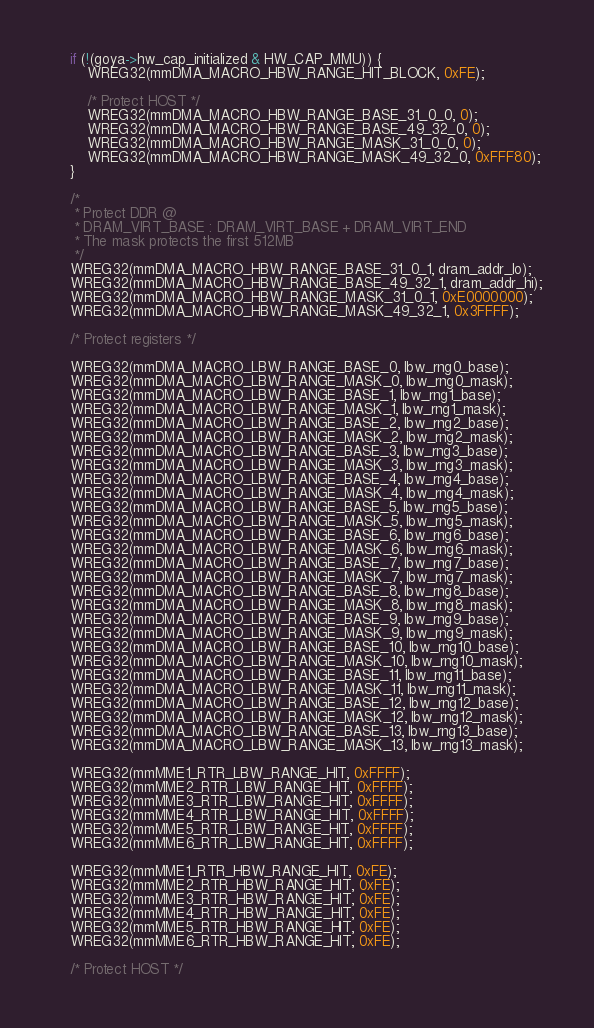<code> <loc_0><loc_0><loc_500><loc_500><_C_>
	if (!(goya->hw_cap_initialized & HW_CAP_MMU)) {
		WREG32(mmDMA_MACRO_HBW_RANGE_HIT_BLOCK, 0xFE);

		/* Protect HOST */
		WREG32(mmDMA_MACRO_HBW_RANGE_BASE_31_0_0, 0);
		WREG32(mmDMA_MACRO_HBW_RANGE_BASE_49_32_0, 0);
		WREG32(mmDMA_MACRO_HBW_RANGE_MASK_31_0_0, 0);
		WREG32(mmDMA_MACRO_HBW_RANGE_MASK_49_32_0, 0xFFF80);
	}

	/*
	 * Protect DDR @
	 * DRAM_VIRT_BASE : DRAM_VIRT_BASE + DRAM_VIRT_END
	 * The mask protects the first 512MB
	 */
	WREG32(mmDMA_MACRO_HBW_RANGE_BASE_31_0_1, dram_addr_lo);
	WREG32(mmDMA_MACRO_HBW_RANGE_BASE_49_32_1, dram_addr_hi);
	WREG32(mmDMA_MACRO_HBW_RANGE_MASK_31_0_1, 0xE0000000);
	WREG32(mmDMA_MACRO_HBW_RANGE_MASK_49_32_1, 0x3FFFF);

	/* Protect registers */

	WREG32(mmDMA_MACRO_LBW_RANGE_BASE_0, lbw_rng0_base);
	WREG32(mmDMA_MACRO_LBW_RANGE_MASK_0, lbw_rng0_mask);
	WREG32(mmDMA_MACRO_LBW_RANGE_BASE_1, lbw_rng1_base);
	WREG32(mmDMA_MACRO_LBW_RANGE_MASK_1, lbw_rng1_mask);
	WREG32(mmDMA_MACRO_LBW_RANGE_BASE_2, lbw_rng2_base);
	WREG32(mmDMA_MACRO_LBW_RANGE_MASK_2, lbw_rng2_mask);
	WREG32(mmDMA_MACRO_LBW_RANGE_BASE_3, lbw_rng3_base);
	WREG32(mmDMA_MACRO_LBW_RANGE_MASK_3, lbw_rng3_mask);
	WREG32(mmDMA_MACRO_LBW_RANGE_BASE_4, lbw_rng4_base);
	WREG32(mmDMA_MACRO_LBW_RANGE_MASK_4, lbw_rng4_mask);
	WREG32(mmDMA_MACRO_LBW_RANGE_BASE_5, lbw_rng5_base);
	WREG32(mmDMA_MACRO_LBW_RANGE_MASK_5, lbw_rng5_mask);
	WREG32(mmDMA_MACRO_LBW_RANGE_BASE_6, lbw_rng6_base);
	WREG32(mmDMA_MACRO_LBW_RANGE_MASK_6, lbw_rng6_mask);
	WREG32(mmDMA_MACRO_LBW_RANGE_BASE_7, lbw_rng7_base);
	WREG32(mmDMA_MACRO_LBW_RANGE_MASK_7, lbw_rng7_mask);
	WREG32(mmDMA_MACRO_LBW_RANGE_BASE_8, lbw_rng8_base);
	WREG32(mmDMA_MACRO_LBW_RANGE_MASK_8, lbw_rng8_mask);
	WREG32(mmDMA_MACRO_LBW_RANGE_BASE_9, lbw_rng9_base);
	WREG32(mmDMA_MACRO_LBW_RANGE_MASK_9, lbw_rng9_mask);
	WREG32(mmDMA_MACRO_LBW_RANGE_BASE_10, lbw_rng10_base);
	WREG32(mmDMA_MACRO_LBW_RANGE_MASK_10, lbw_rng10_mask);
	WREG32(mmDMA_MACRO_LBW_RANGE_BASE_11, lbw_rng11_base);
	WREG32(mmDMA_MACRO_LBW_RANGE_MASK_11, lbw_rng11_mask);
	WREG32(mmDMA_MACRO_LBW_RANGE_BASE_12, lbw_rng12_base);
	WREG32(mmDMA_MACRO_LBW_RANGE_MASK_12, lbw_rng12_mask);
	WREG32(mmDMA_MACRO_LBW_RANGE_BASE_13, lbw_rng13_base);
	WREG32(mmDMA_MACRO_LBW_RANGE_MASK_13, lbw_rng13_mask);

	WREG32(mmMME1_RTR_LBW_RANGE_HIT, 0xFFFF);
	WREG32(mmMME2_RTR_LBW_RANGE_HIT, 0xFFFF);
	WREG32(mmMME3_RTR_LBW_RANGE_HIT, 0xFFFF);
	WREG32(mmMME4_RTR_LBW_RANGE_HIT, 0xFFFF);
	WREG32(mmMME5_RTR_LBW_RANGE_HIT, 0xFFFF);
	WREG32(mmMME6_RTR_LBW_RANGE_HIT, 0xFFFF);

	WREG32(mmMME1_RTR_HBW_RANGE_HIT, 0xFE);
	WREG32(mmMME2_RTR_HBW_RANGE_HIT, 0xFE);
	WREG32(mmMME3_RTR_HBW_RANGE_HIT, 0xFE);
	WREG32(mmMME4_RTR_HBW_RANGE_HIT, 0xFE);
	WREG32(mmMME5_RTR_HBW_RANGE_HIT, 0xFE);
	WREG32(mmMME6_RTR_HBW_RANGE_HIT, 0xFE);

	/* Protect HOST */</code> 